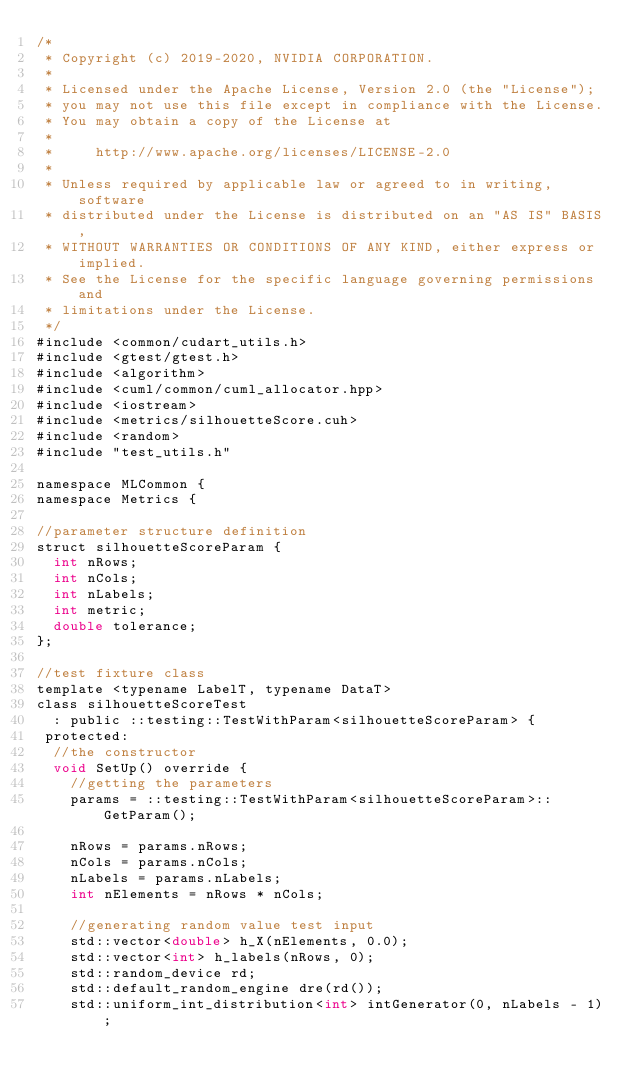<code> <loc_0><loc_0><loc_500><loc_500><_Cuda_>/*
 * Copyright (c) 2019-2020, NVIDIA CORPORATION.
 *
 * Licensed under the Apache License, Version 2.0 (the "License");
 * you may not use this file except in compliance with the License.
 * You may obtain a copy of the License at
 *
 *     http://www.apache.org/licenses/LICENSE-2.0
 *
 * Unless required by applicable law or agreed to in writing, software
 * distributed under the License is distributed on an "AS IS" BASIS,
 * WITHOUT WARRANTIES OR CONDITIONS OF ANY KIND, either express or implied.
 * See the License for the specific language governing permissions and
 * limitations under the License.
 */
#include <common/cudart_utils.h>
#include <gtest/gtest.h>
#include <algorithm>
#include <cuml/common/cuml_allocator.hpp>
#include <iostream>
#include <metrics/silhouetteScore.cuh>
#include <random>
#include "test_utils.h"

namespace MLCommon {
namespace Metrics {

//parameter structure definition
struct silhouetteScoreParam {
  int nRows;
  int nCols;
  int nLabels;
  int metric;
  double tolerance;
};

//test fixture class
template <typename LabelT, typename DataT>
class silhouetteScoreTest
  : public ::testing::TestWithParam<silhouetteScoreParam> {
 protected:
  //the constructor
  void SetUp() override {
    //getting the parameters
    params = ::testing::TestWithParam<silhouetteScoreParam>::GetParam();

    nRows = params.nRows;
    nCols = params.nCols;
    nLabels = params.nLabels;
    int nElements = nRows * nCols;

    //generating random value test input
    std::vector<double> h_X(nElements, 0.0);
    std::vector<int> h_labels(nRows, 0);
    std::random_device rd;
    std::default_random_engine dre(rd());
    std::uniform_int_distribution<int> intGenerator(0, nLabels - 1);</code> 